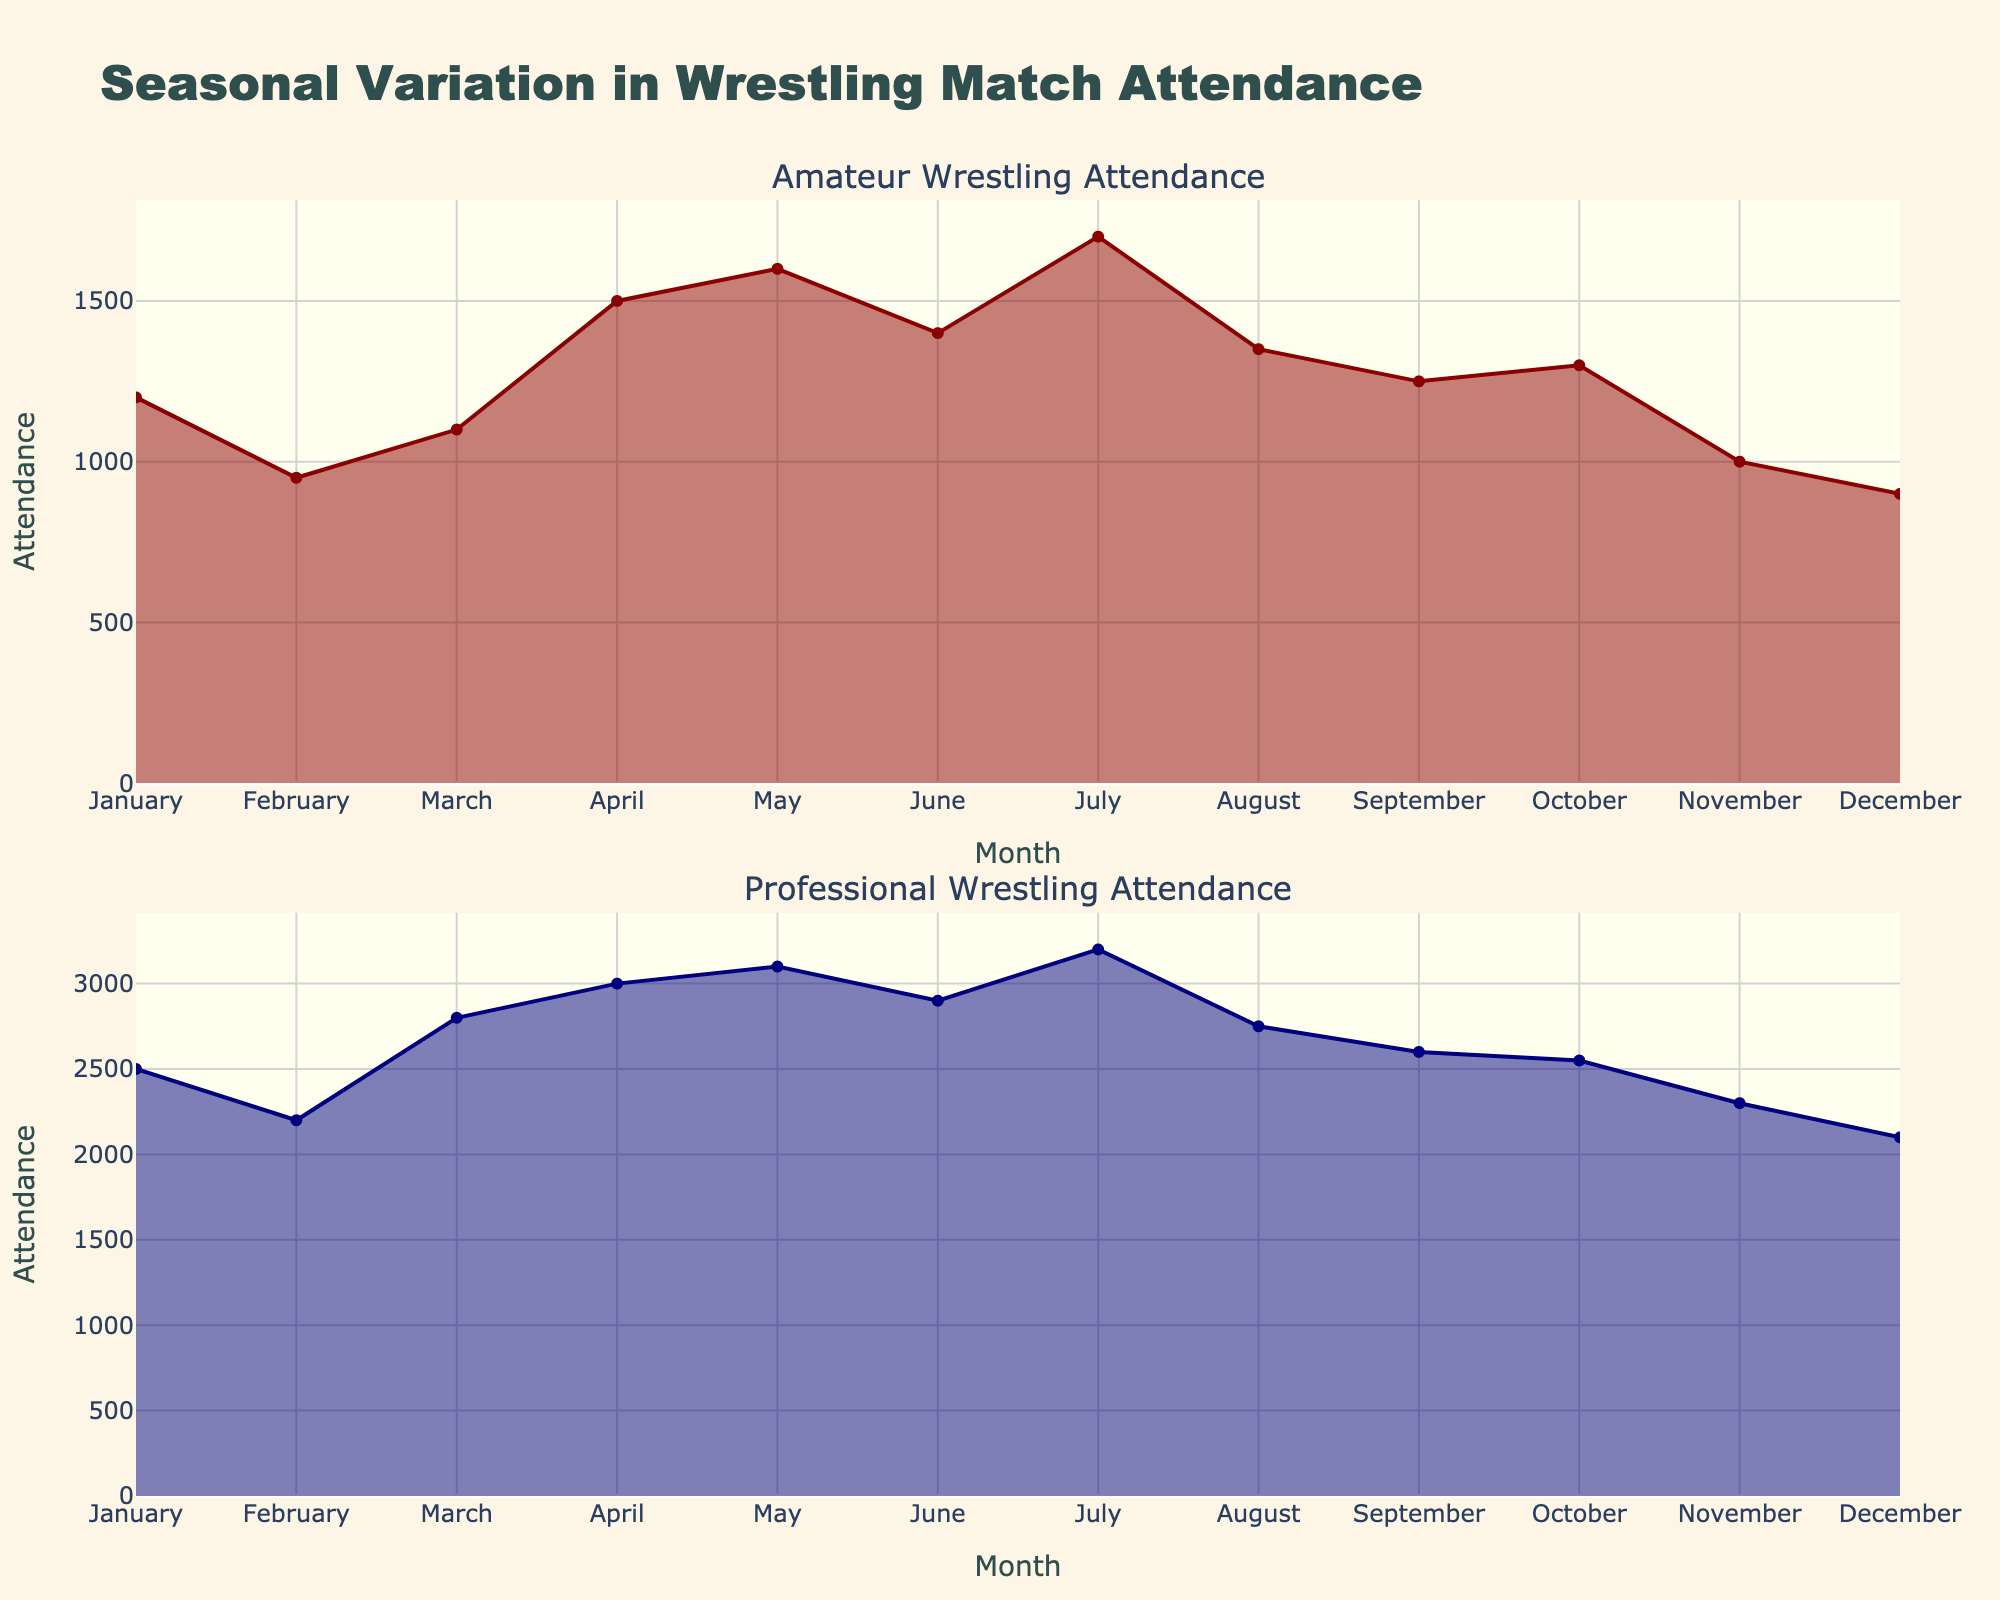What is the title of the figure? The title is located at the top of the figure and it describes what the figure is about. Here, it reads "Seasonal Variation in Wrestling Match Attendance".
Answer: Seasonal Variation in Wrestling Match Attendance What color is used to represent amateur wrestling attendance? The color used can be seen from the trace of the amateur subplot. It is dark red.
Answer: Dark red In which month is the attendance highest for professional wrestling events? By looking at the peaks in the professional wrestling subplot, July is where the attendance is the highest.
Answer: July What is the attendance for amateur wrestling in April? Find April in the amateur subplot and read the corresponding attendance value, which is 1500.
Answer: 1500 What is the difference in attendance between professional wrestling events in January and December? Attendance in January is 2500 and in December is 2100. Subtract to find the difference: 2500 - 2100 = 400.
Answer: 400 What is the average attendance for amateur wrestling events in the first quarter (January to March)? Sum the attendance values for January, February, and March: 1200 + 950 + 1100 = 3250. Divide by 3 to find the average: 3250 / 3 ≈ 1083.
Answer: 1083 Which subplot shows higher overall attendance, amateur or professional wrestling? By comparing the height of the area fills in both subplots over the entire year, the professional wrestling subplot clearly shows higher overall attendance.
Answer: Professional wrestling Which month shows the lowest attendance for amateur wrestling events? In the amateur subplot, the lowest point is in December with an attendance of 900.
Answer: December Comparing the peak attendance months, which type of wrestling has a higher peak attendance? For amateur wrestling, the peak is July at 1700. For professional wrestling, the peak is July at 3200. Professional wrestling has a higher peak.
Answer: Professional 